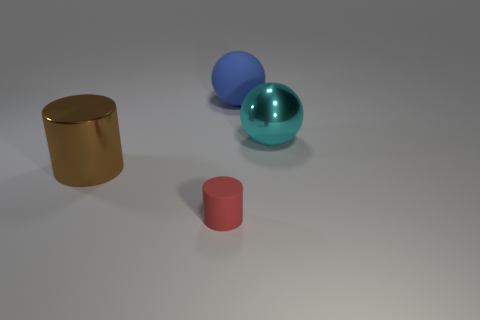There is a blue ball that is the same size as the metal cylinder; what material is it?
Offer a very short reply. Rubber. Does the metallic cylinder have the same color as the matte cylinder?
Your answer should be very brief. No. Are there any cylinders that have the same size as the blue sphere?
Your answer should be compact. Yes. How big is the thing in front of the shiny object in front of the cyan shiny ball?
Ensure brevity in your answer.  Small. What shape is the matte object behind the shiny thing in front of the cyan sphere?
Give a very brief answer. Sphere. How many small cylinders are the same material as the brown thing?
Your answer should be compact. 0. There is a ball in front of the big blue matte ball; what material is it?
Offer a terse response. Metal. There is a matte object right of the rubber thing that is to the left of the rubber thing behind the large cylinder; what shape is it?
Offer a very short reply. Sphere. Is the color of the metal object to the right of the big metallic cylinder the same as the matte thing that is in front of the blue rubber thing?
Give a very brief answer. No. Is the number of large metal objects that are in front of the big brown shiny cylinder less than the number of tiny cylinders to the left of the small red matte cylinder?
Your answer should be compact. No. 